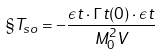<formula> <loc_0><loc_0><loc_500><loc_500>\S T _ { s o } = - \frac { \epsilon t \cdot \Gamma t ( 0 ) \cdot \epsilon t } { M _ { 0 } ^ { 2 } V }</formula> 